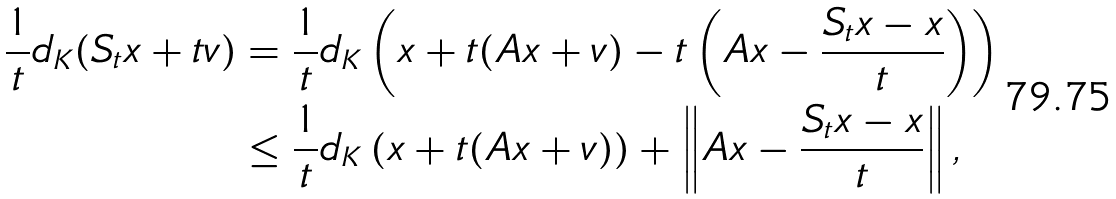<formula> <loc_0><loc_0><loc_500><loc_500>\frac { 1 } { t } d _ { K } ( S _ { t } x + t v ) & = \frac { 1 } { t } d _ { K } \left ( x + t ( A x + v ) - t \left ( A x - \frac { S _ { t } x - x } { t } \right ) \right ) \\ & \leq \frac { 1 } { t } d _ { K } \left ( x + t ( A x + v ) \right ) + \left \| A x - \frac { S _ { t } x - x } { t } \right \| ,</formula> 